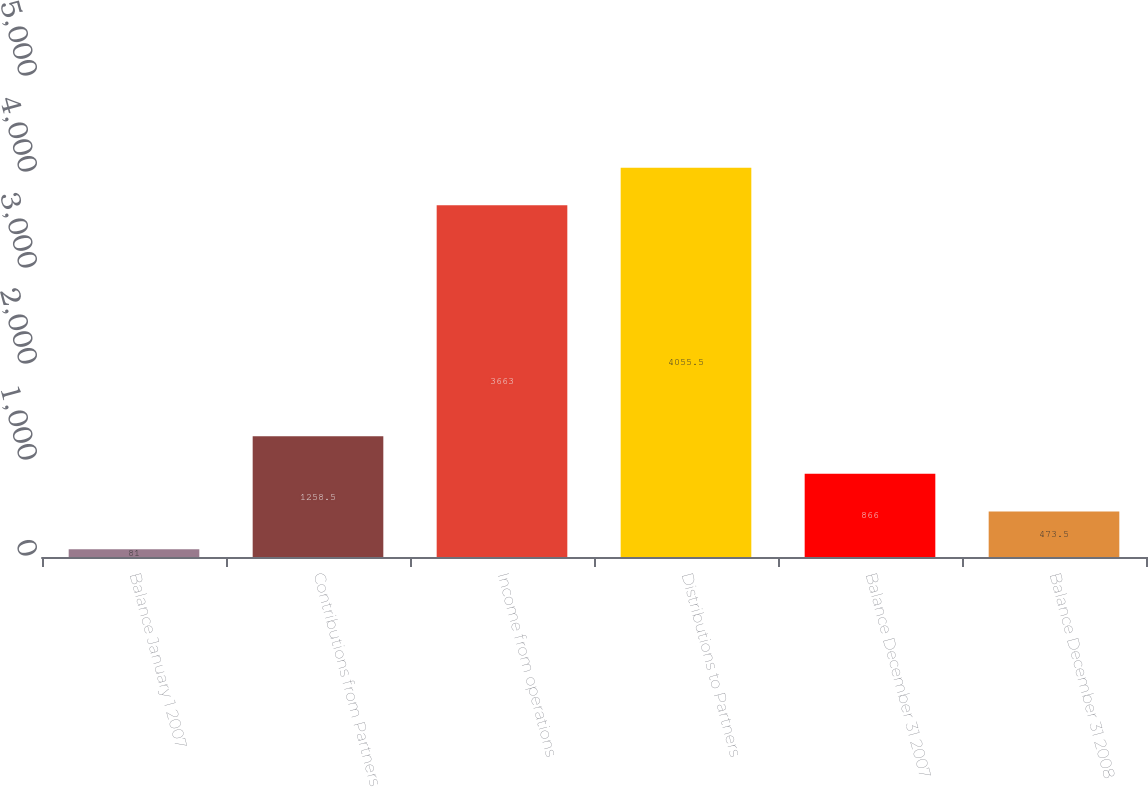Convert chart to OTSL. <chart><loc_0><loc_0><loc_500><loc_500><bar_chart><fcel>Balance January 1 2007<fcel>Contributions from Partners<fcel>Income from operations<fcel>Distributions to Partners<fcel>Balance December 31 2007<fcel>Balance December 31 2008<nl><fcel>81<fcel>1258.5<fcel>3663<fcel>4055.5<fcel>866<fcel>473.5<nl></chart> 